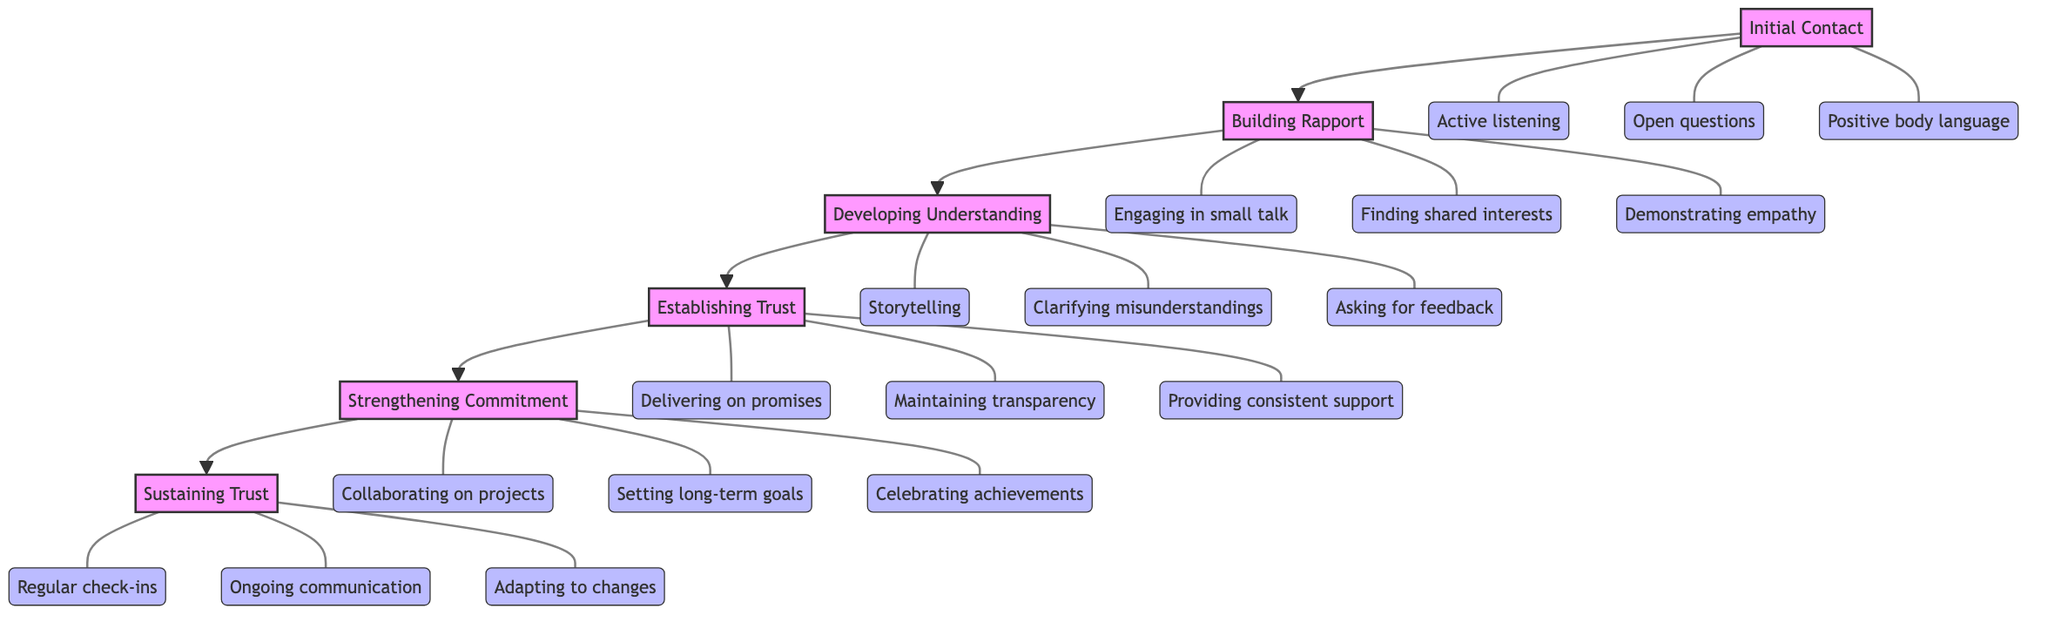What is the first stage in the growth sequence? The diagram begins with "Initial Contact" at the bottom, indicating it is the first stage in the sequence.
Answer: Initial Contact How many total stages are represented in the diagram? By counting the stages listed from "Initial Contact" to "Sustaining Trust", there are a total of six distinct stages depicted in the diagram.
Answer: 6 Which strategies are associated with establishing trust? Looking at the strategies linked to the "Establishing Trust" stage, the strategies listed are "Delivering on promises", "Maintaining transparency", and "Providing consistent support".
Answer: Delivering on promises, Maintaining transparency, Providing consistent support What is the last stage in the growth process? At the top of the diagram, "Sustaining Trust" is the final stage of the growth process, indicating it is the most advanced level of trust-building.
Answer: Sustaining Trust Which stage follows "Developing Understanding"? Following the sequence illustrated, the stage that comes directly after "Developing Understanding" is "Establishing Trust".
Answer: Establishing Trust How many strategies are associated with strengthening commitment? The count of strategies related to "Strengthening Commitment" includes "Collaborating on projects", "Setting long-term goals", and "Celebrating achievements", which totals three strategies.
Answer: 3 What is the relationship between Building Rapport and Developing Understanding? In the flow of the diagram, "Building Rapport" leads to "Developing Understanding", indicating they are directly connected where Building Rapport is the precursor to Developing Understanding.
Answer: Building Rapport leads to Developing Understanding What strategies involve maintaining long-term relationships? The strategies listed under "Sustaining Trust" focus on maintaining relationships and include "Regular check-ins", "Ongoing communication", and "Adapting to changes".
Answer: Regular check-ins, Ongoing communication, Adapting to changes What type of diagram is represented here? The diagram showcases a Bottom to Top Flow Chart, which visually demonstrates a process where elements are organized in a vertical sequence with arrows indicating upward movement.
Answer: Bottom to Top Flow Chart 